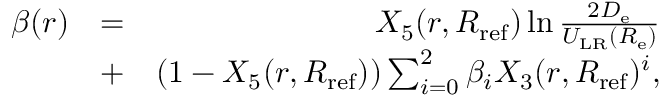<formula> <loc_0><loc_0><loc_500><loc_500>\begin{array} { r l r } { \beta ( r ) } & { = } & { X _ { 5 } ( r , R _ { r e f } ) \ln \frac { 2 D _ { e } } { U _ { L R } ( R _ { e } ) } } \\ & { + } & { ( 1 - X _ { 5 } ( r , R _ { r e f } ) ) \sum _ { i = 0 } ^ { 2 } \beta _ { i } X _ { 3 } ( r , R _ { r e f } ) ^ { i } , } \end{array}</formula> 